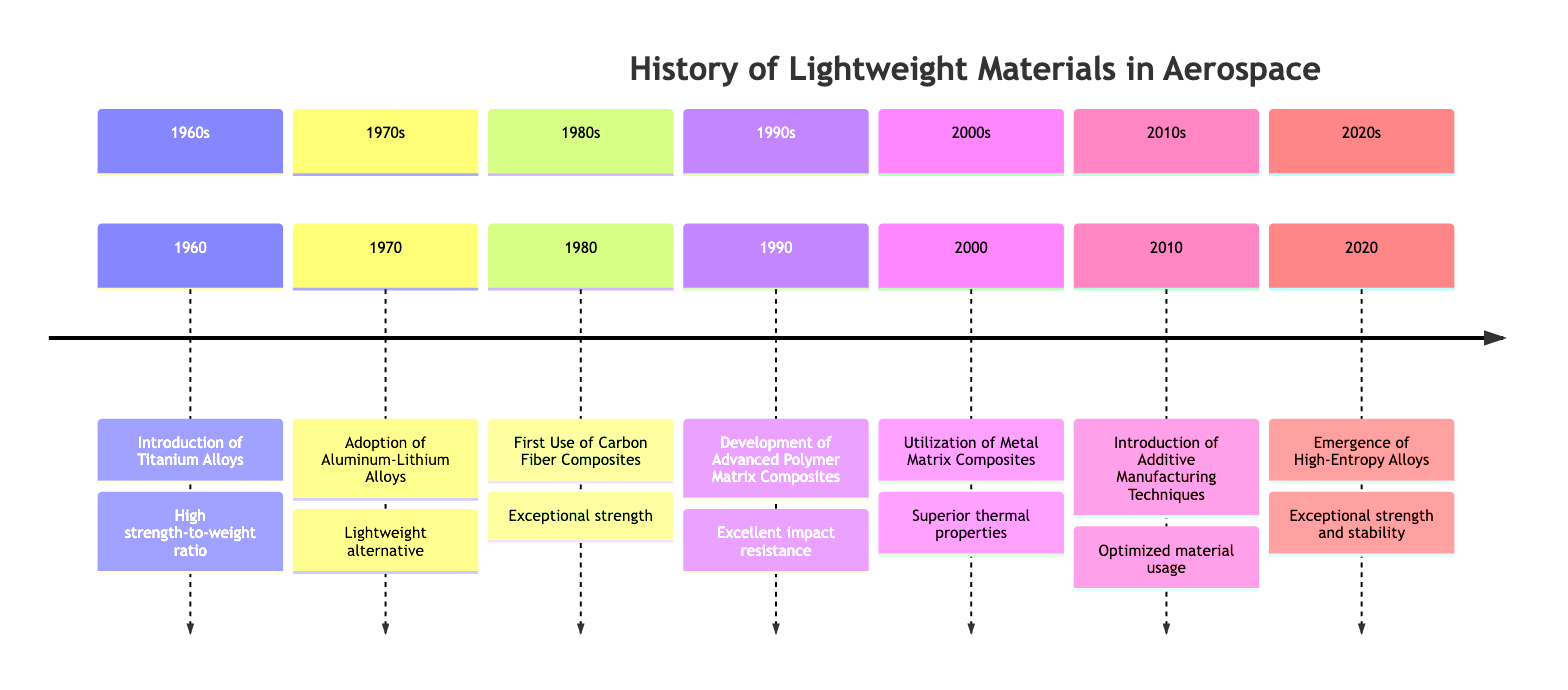What event occurred in 1980? The diagram explicitly states that in 1980, the "First Use of Carbon Fiber Composites" occurred.
Answer: First Use of Carbon Fiber Composites How many significant events are shown in the timeline? By counting the number of individual events listed in the timeline, there are a total of 7 events presented from 1960 to 2020.
Answer: 7 Which lightweight material was introduced in 1970? Referring to the timeline, the material introduced in 1970 is "Aluminum-Lithium Alloys."
Answer: Aluminum-Lithium Alloys What is the significance of the event in 2000? The significance is highlighted in the description, which states the utilization of "Metal Matrix Composites" began, focusing on high-performance aerospace applications.
Answer: Metal Matrix Composites What materials were first introduced in the 1960s? The timeline indicates that the material introduced in the 1960s was "Titanium Alloys," marking an important development in lightweight materials.
Answer: Titanium Alloys What material technology was introduced around 2010? The timeline describes the event of 2010 as the "Introduction of Additive Manufacturing Techniques."
Answer: Additive Manufacturing Techniques What characteristics are attributed to High-Entropy Alloys introduced in 2020? According to the description, High-Entropy Alloys are known for their "exceptional strength, thermal stability, and damage tolerance," which are critical features for aerospace applications.
Answer: Exceptional strength, thermal stability, and damage tolerance Which composite was developed for impact resistance in the 1990s? The timeline mentions "Advanced Polymer Matrix Composites" to have been developed in the 1990s, specifically for their excellent impact resistance.
Answer: Advanced Polymer Matrix Composites 